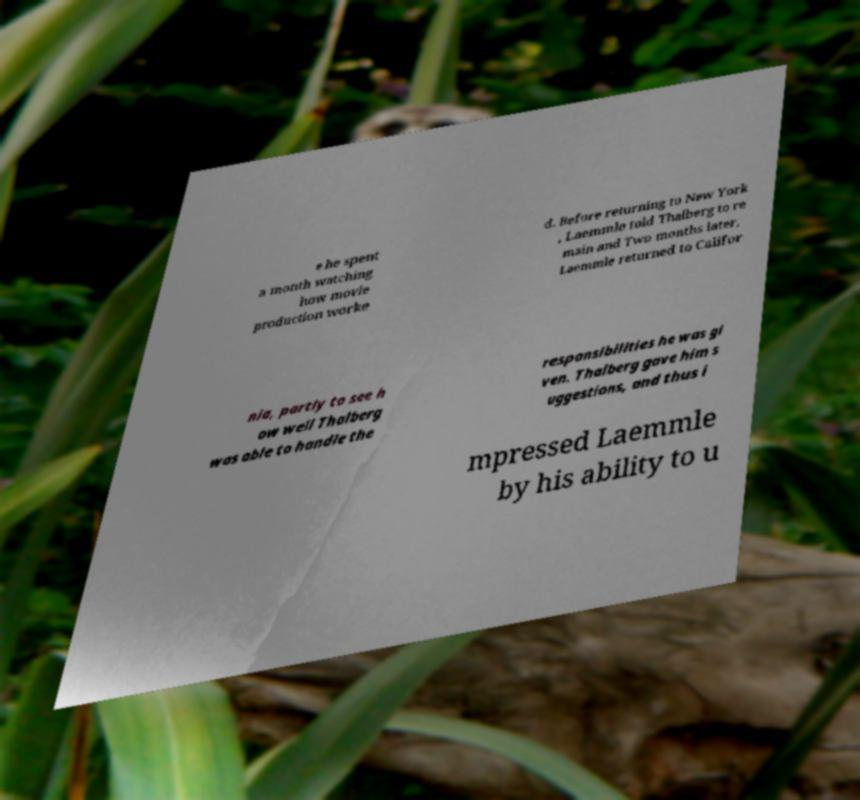Could you assist in decoding the text presented in this image and type it out clearly? e he spent a month watching how movie production worke d. Before returning to New York , Laemmle told Thalberg to re main and Two months later, Laemmle returned to Califor nia, partly to see h ow well Thalberg was able to handle the responsibilities he was gi ven. Thalberg gave him s uggestions, and thus i mpressed Laemmle by his ability to u 